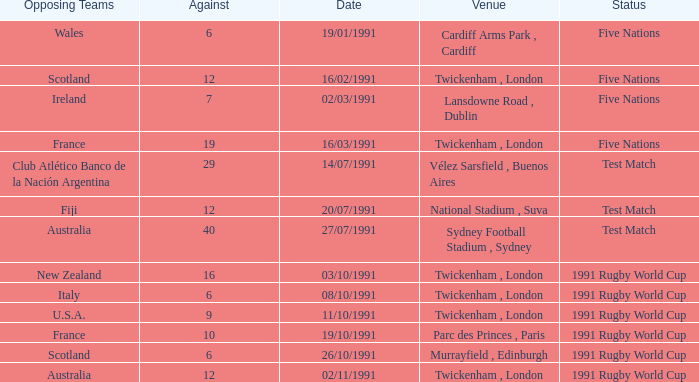What is Date, when Opposing Teams is "Australia", and when Venue is "Twickenham , London"? 02/11/1991. 